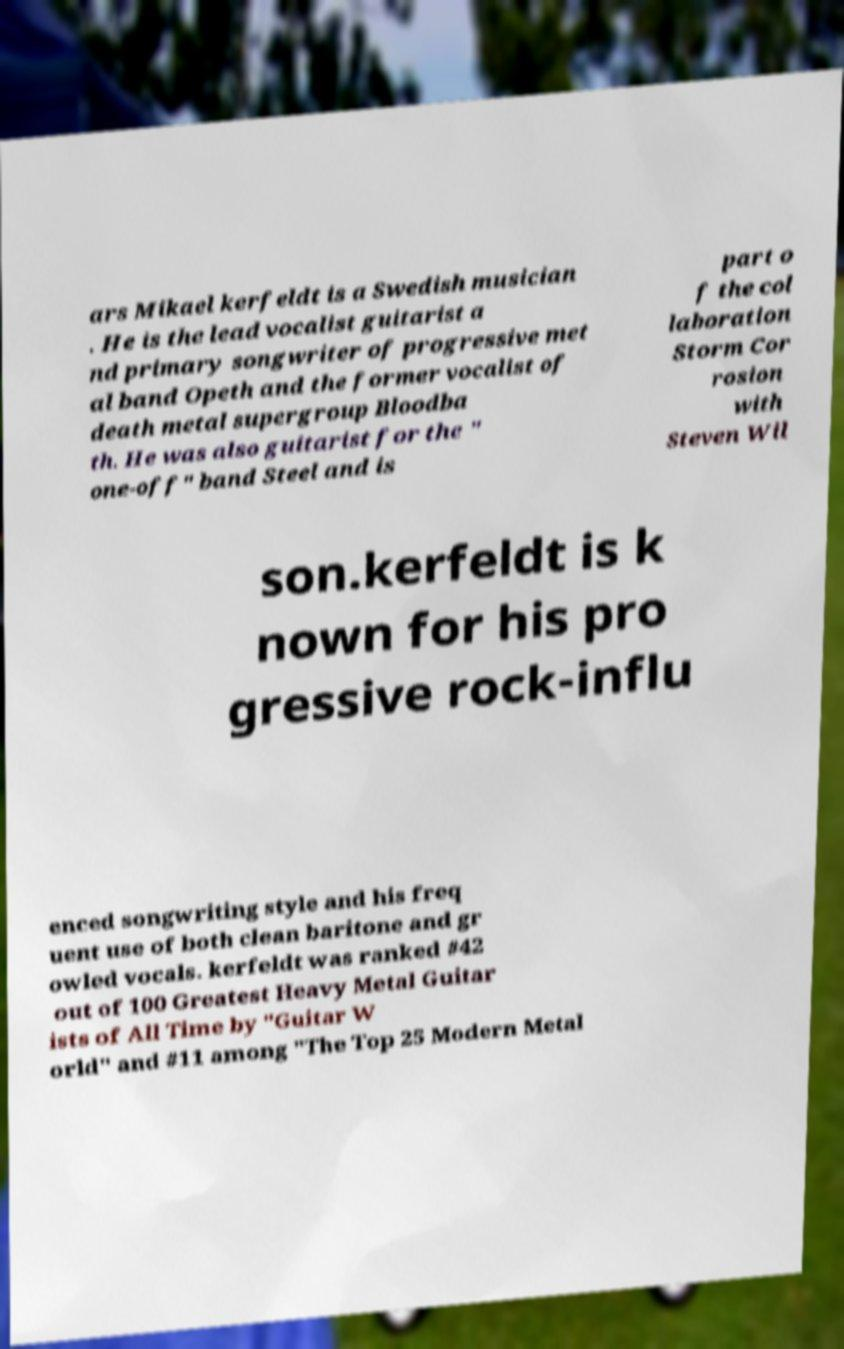Please identify and transcribe the text found in this image. ars Mikael kerfeldt is a Swedish musician . He is the lead vocalist guitarist a nd primary songwriter of progressive met al band Opeth and the former vocalist of death metal supergroup Bloodba th. He was also guitarist for the " one-off" band Steel and is part o f the col laboration Storm Cor rosion with Steven Wil son.kerfeldt is k nown for his pro gressive rock-influ enced songwriting style and his freq uent use of both clean baritone and gr owled vocals. kerfeldt was ranked #42 out of 100 Greatest Heavy Metal Guitar ists of All Time by "Guitar W orld" and #11 among "The Top 25 Modern Metal 